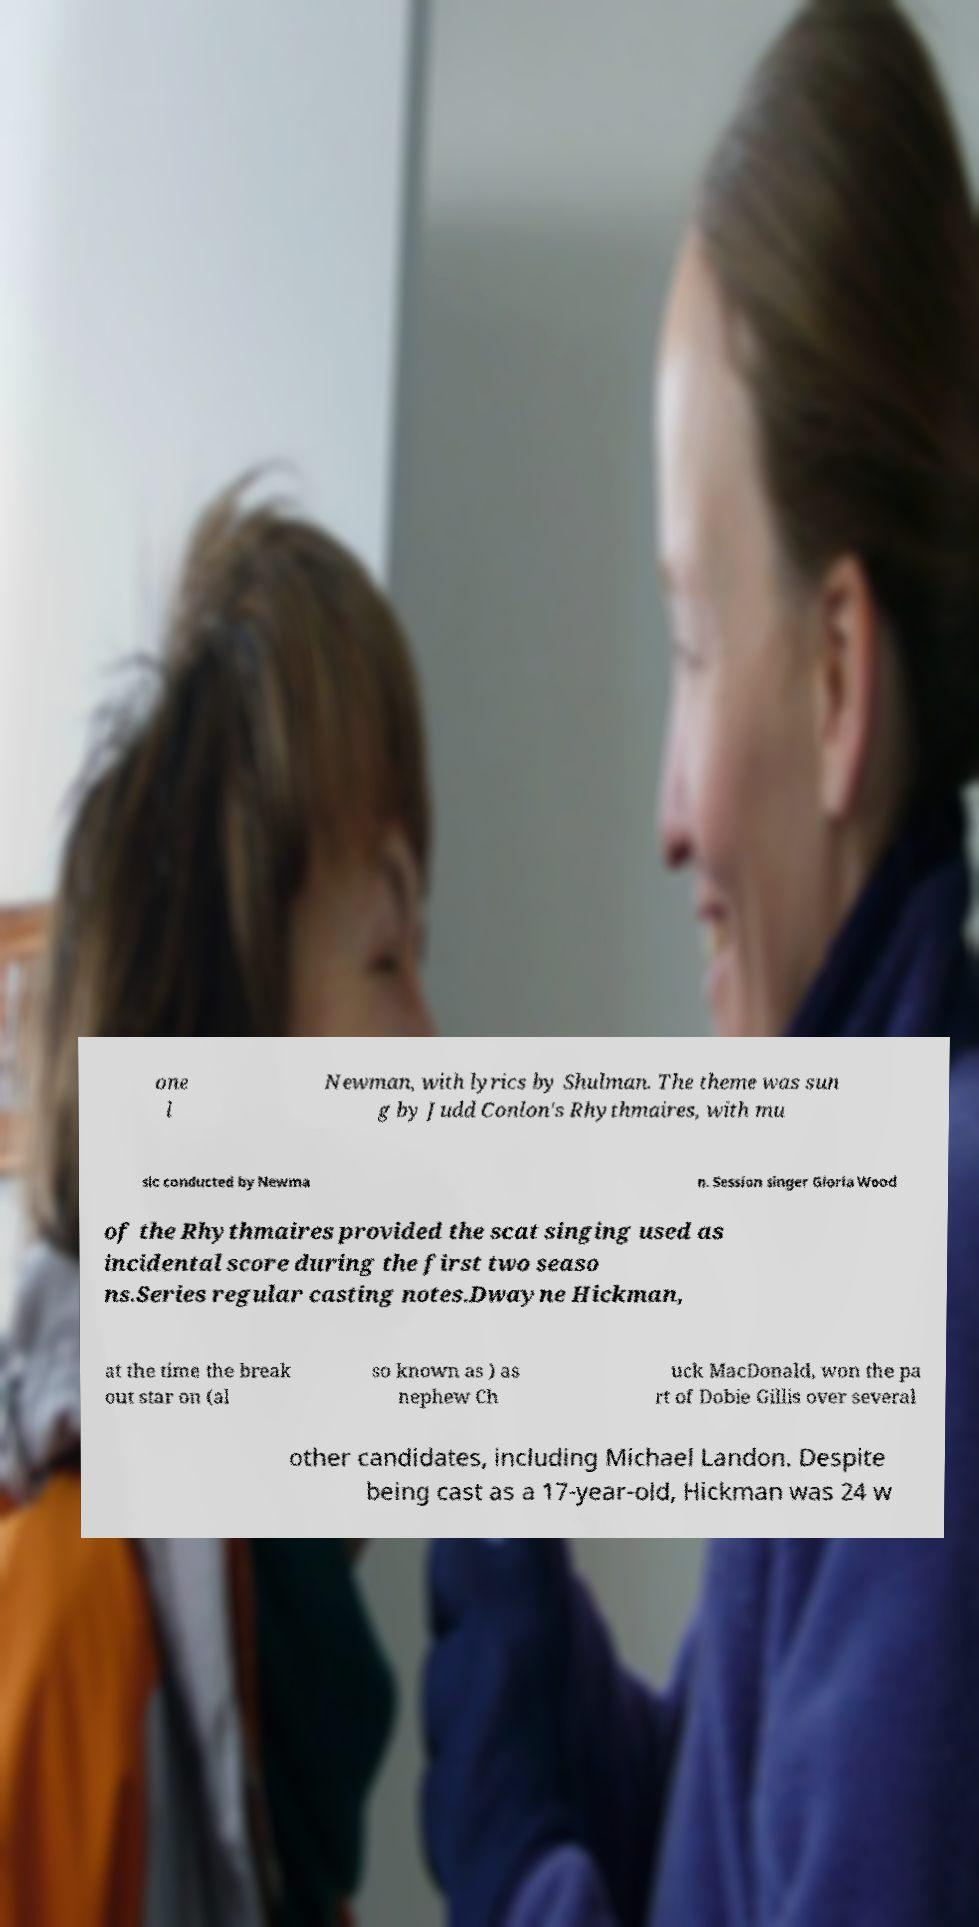I need the written content from this picture converted into text. Can you do that? one l Newman, with lyrics by Shulman. The theme was sun g by Judd Conlon's Rhythmaires, with mu sic conducted by Newma n. Session singer Gloria Wood of the Rhythmaires provided the scat singing used as incidental score during the first two seaso ns.Series regular casting notes.Dwayne Hickman, at the time the break out star on (al so known as ) as nephew Ch uck MacDonald, won the pa rt of Dobie Gillis over several other candidates, including Michael Landon. Despite being cast as a 17-year-old, Hickman was 24 w 